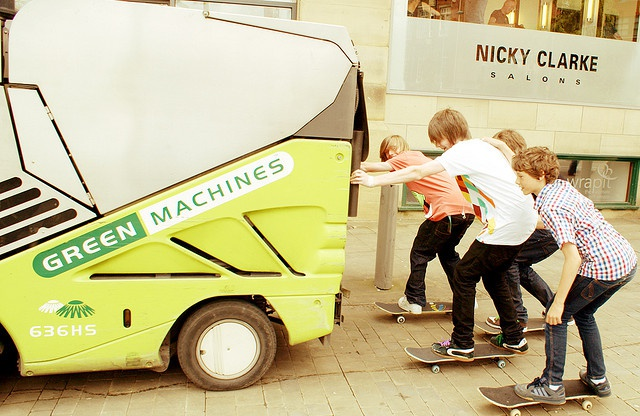Describe the objects in this image and their specific colors. I can see truck in maroon, ivory, khaki, and black tones, people in maroon, white, black, khaki, and tan tones, people in maroon, white, black, tan, and gray tones, people in maroon, black, tan, and beige tones, and people in maroon, black, tan, and khaki tones in this image. 